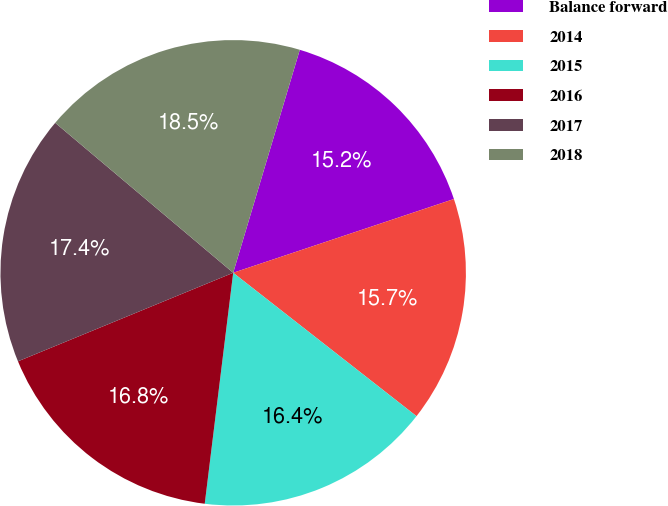Convert chart. <chart><loc_0><loc_0><loc_500><loc_500><pie_chart><fcel>Balance forward<fcel>2014<fcel>2015<fcel>2016<fcel>2017<fcel>2018<nl><fcel>15.25%<fcel>15.7%<fcel>16.39%<fcel>16.84%<fcel>17.36%<fcel>18.48%<nl></chart> 